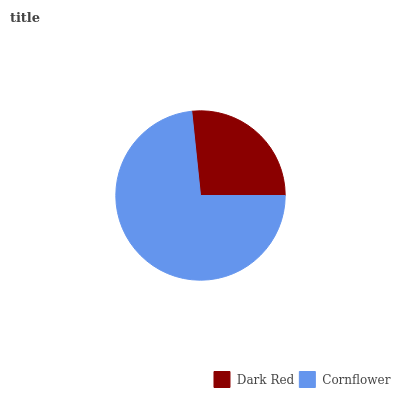Is Dark Red the minimum?
Answer yes or no. Yes. Is Cornflower the maximum?
Answer yes or no. Yes. Is Cornflower the minimum?
Answer yes or no. No. Is Cornflower greater than Dark Red?
Answer yes or no. Yes. Is Dark Red less than Cornflower?
Answer yes or no. Yes. Is Dark Red greater than Cornflower?
Answer yes or no. No. Is Cornflower less than Dark Red?
Answer yes or no. No. Is Cornflower the high median?
Answer yes or no. Yes. Is Dark Red the low median?
Answer yes or no. Yes. Is Dark Red the high median?
Answer yes or no. No. Is Cornflower the low median?
Answer yes or no. No. 